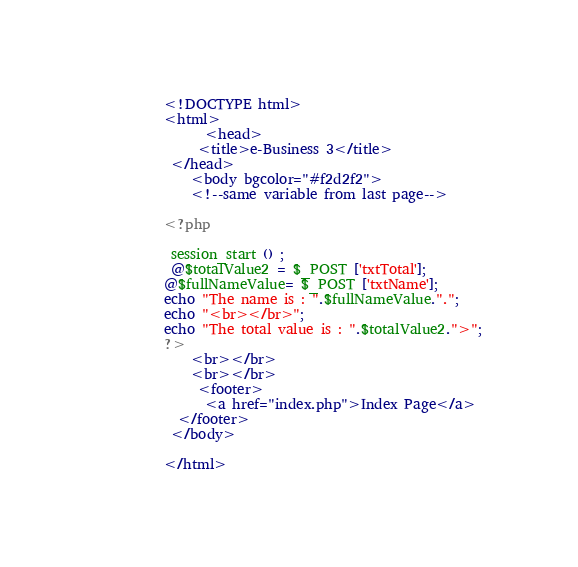<code> <loc_0><loc_0><loc_500><loc_500><_PHP_>    <!DOCTYPE html>
    <html>
          <head>
         <title>e-Business 3</title>
     </head>
        <body bgcolor="#f2d2f2">   
        <!--same variable from last page-->
   
    <?php
 
     session_start () ;
     @$totalValue2 = $_POST ['txtTotal'];
    @$fullNameValue= $_POST ['txtName'];
    echo "The name is : ".$fullNameValue.".";
    echo "<br></br>";
    echo "The total value is : ".$totalValue2.">";
    ?>
        <br></br>
        <br></br>
         <footer>
          <a href="index.php">Index Page</a>
      </footer>
     </body>
     
    </html></code> 